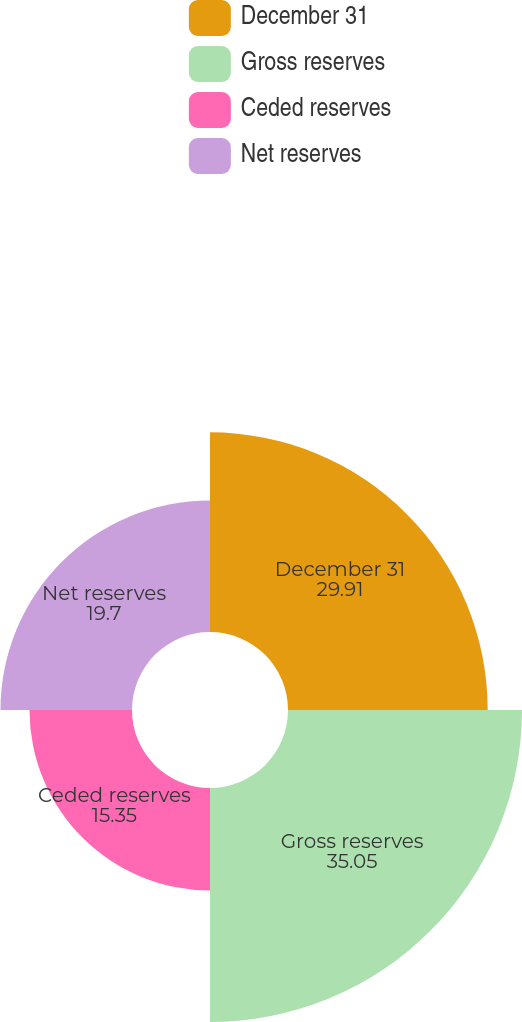Convert chart to OTSL. <chart><loc_0><loc_0><loc_500><loc_500><pie_chart><fcel>December 31<fcel>Gross reserves<fcel>Ceded reserves<fcel>Net reserves<nl><fcel>29.91%<fcel>35.05%<fcel>15.35%<fcel>19.7%<nl></chart> 